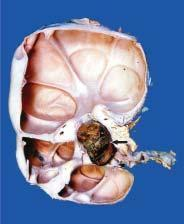what are these cysts communicating with?
Answer the question using a single word or phrase. Pelvi-calyceal system unlike polycystic kidney 